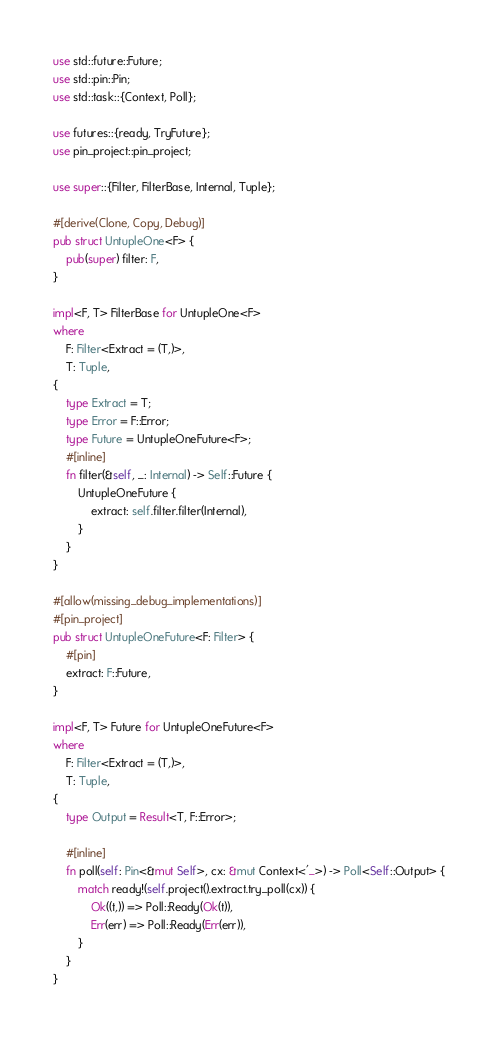<code> <loc_0><loc_0><loc_500><loc_500><_Rust_>use std::future::Future;
use std::pin::Pin;
use std::task::{Context, Poll};

use futures::{ready, TryFuture};
use pin_project::pin_project;

use super::{Filter, FilterBase, Internal, Tuple};

#[derive(Clone, Copy, Debug)]
pub struct UntupleOne<F> {
    pub(super) filter: F,
}

impl<F, T> FilterBase for UntupleOne<F>
where
    F: Filter<Extract = (T,)>,
    T: Tuple,
{
    type Extract = T;
    type Error = F::Error;
    type Future = UntupleOneFuture<F>;
    #[inline]
    fn filter(&self, _: Internal) -> Self::Future {
        UntupleOneFuture {
            extract: self.filter.filter(Internal),
        }
    }
}

#[allow(missing_debug_implementations)]
#[pin_project]
pub struct UntupleOneFuture<F: Filter> {
    #[pin]
    extract: F::Future,
}

impl<F, T> Future for UntupleOneFuture<F>
where
    F: Filter<Extract = (T,)>,
    T: Tuple,
{
    type Output = Result<T, F::Error>;

    #[inline]
    fn poll(self: Pin<&mut Self>, cx: &mut Context<'_>) -> Poll<Self::Output> {
        match ready!(self.project().extract.try_poll(cx)) {
            Ok((t,)) => Poll::Ready(Ok(t)),
            Err(err) => Poll::Ready(Err(err)),
        }
    }
}
</code> 